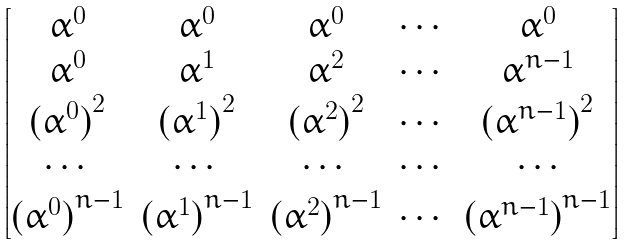Convert formula to latex. <formula><loc_0><loc_0><loc_500><loc_500>\begin{bmatrix} \alpha ^ { 0 } & \alpha ^ { 0 } & \alpha ^ { 0 } & \cdots & \alpha ^ { 0 } \\ \alpha ^ { 0 } & \alpha ^ { 1 } & \alpha ^ { 2 } & \cdots & \alpha ^ { n - 1 } \\ { ( \alpha ^ { 0 } ) } ^ { 2 } & { ( \alpha ^ { 1 } ) } ^ { 2 } & { ( \alpha ^ { 2 } ) } ^ { 2 } & \cdots & { ( \alpha ^ { n - 1 } ) } ^ { 2 } \\ \cdots & \cdots & \cdots & \cdots & \cdots \\ { ( \alpha ^ { 0 } ) } ^ { n - 1 } & { ( \alpha ^ { 1 } ) } ^ { n - 1 } & { ( \alpha ^ { 2 } ) } ^ { n - 1 } & \cdots & { ( \alpha ^ { n - 1 } ) } ^ { n - 1 } \\ \end{bmatrix}</formula> 